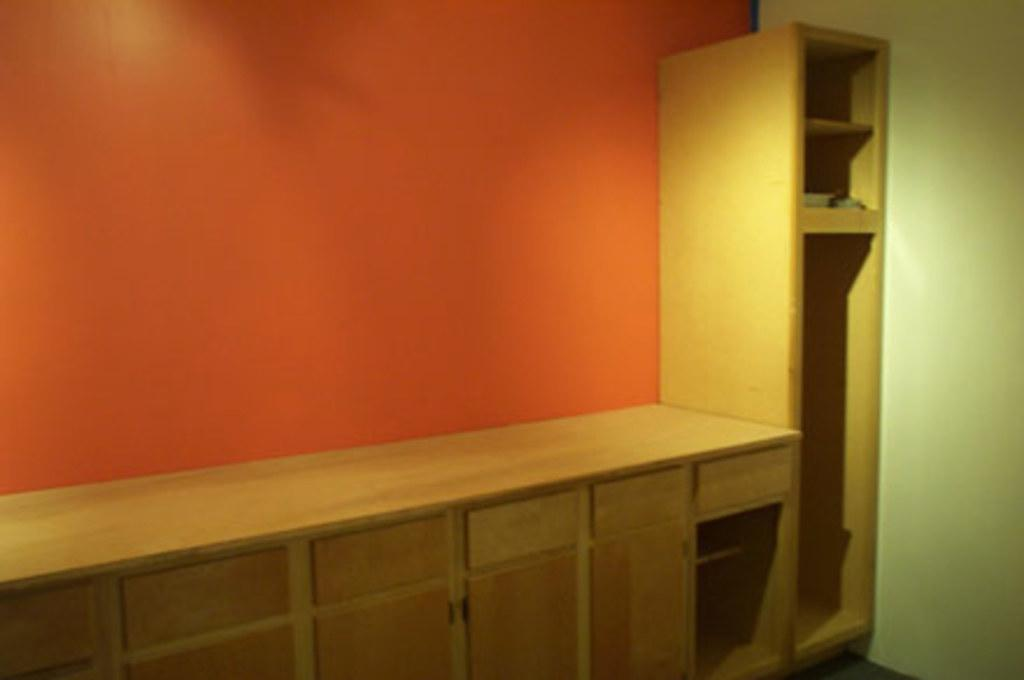What type of furniture is present in the image? There is a cupboard in the image. What type of structure can be seen on the right side of the image? There is a wall present on the right side of the image. Can you describe the wall in the image? The wall is a vertical structure that provides support and separation in the image. What type of stem is visible on the wall in the image? There is no stem visible on the wall in the image. What type of fuel is used to power the cupboard in the image? The cupboard does not require fuel to function, as it is a stationary piece of furniture. 